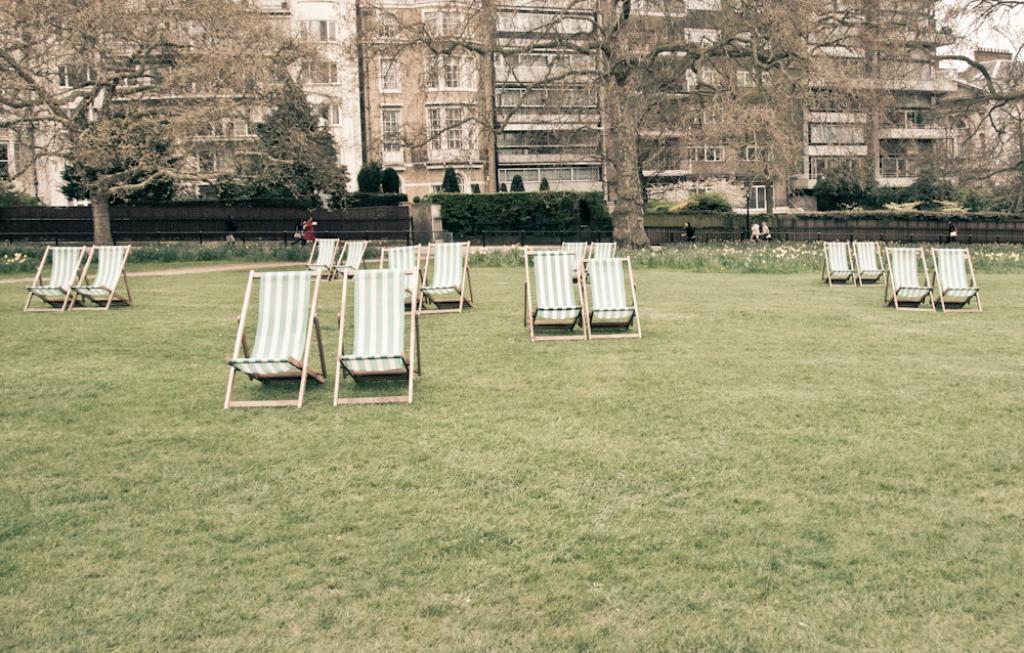How would you summarize this image in a sentence or two? In this picture we can see many chairs in the park. On the bottom we can see grass. On the background we can see building, trees, plants and wall. On the top right corner there is a sky. Here we can see a woman who is wearing red dress. 